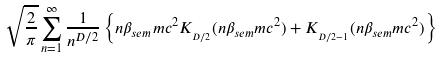Convert formula to latex. <formula><loc_0><loc_0><loc_500><loc_500>\sqrt { \frac { 2 } { \pi } } \sum _ { n = 1 } ^ { \infty } \frac { 1 } { n ^ { D / 2 } } \left \{ n \beta _ { s e m } m c ^ { 2 } K _ { _ { D / 2 } } ( n \beta _ { s e m } m c ^ { 2 } ) + K _ { _ { D / 2 - 1 } } ( n \beta _ { s e m } m c ^ { 2 } ) \right \}</formula> 